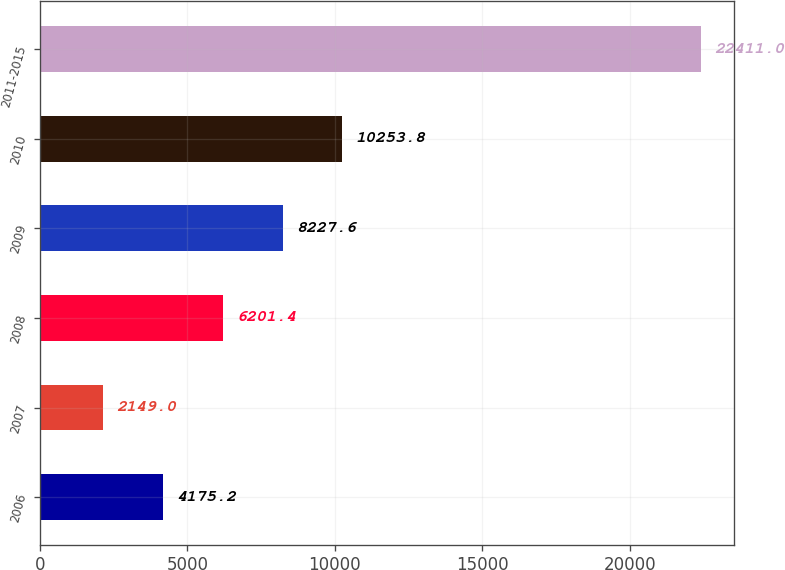Convert chart. <chart><loc_0><loc_0><loc_500><loc_500><bar_chart><fcel>2006<fcel>2007<fcel>2008<fcel>2009<fcel>2010<fcel>2011-2015<nl><fcel>4175.2<fcel>2149<fcel>6201.4<fcel>8227.6<fcel>10253.8<fcel>22411<nl></chart> 